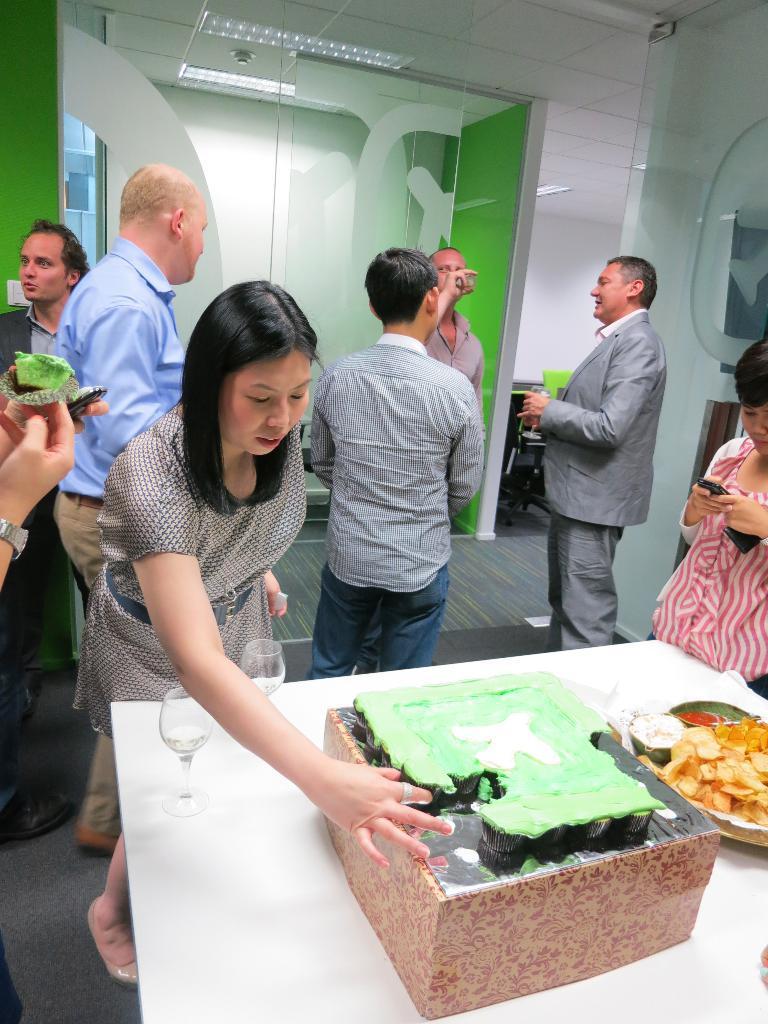Could you give a brief overview of what you see in this image? In this picture I can see a table in front on which there are food items and I can see 2 glasses. In the middle of this picture I can see few people who are holding things in their hands. In the background I can see the glasses and I can see the lights on the ceiling. 